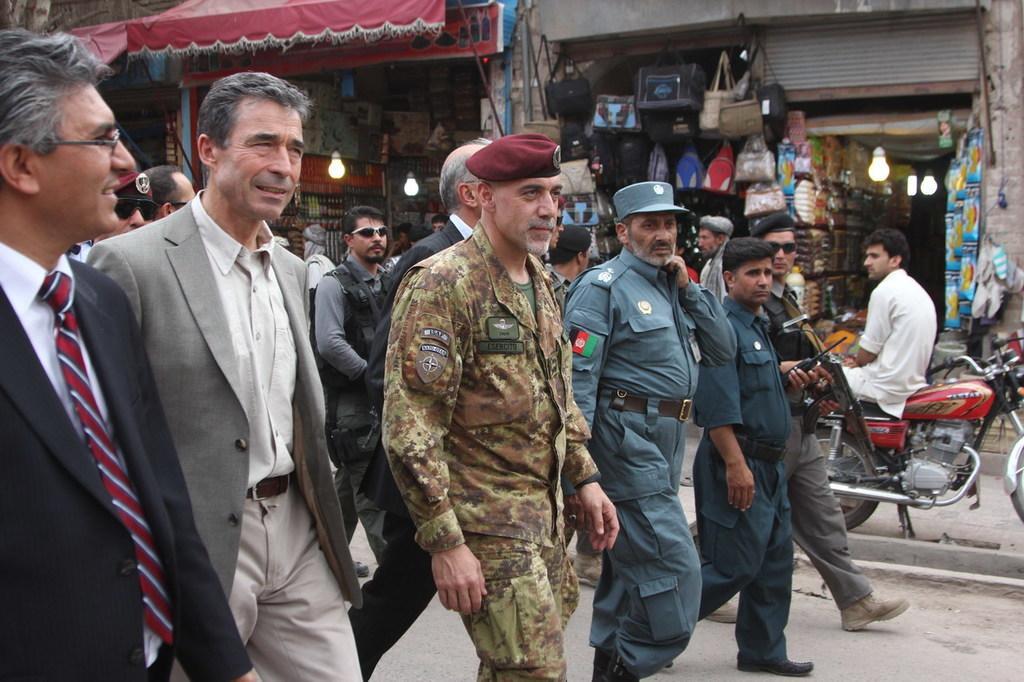Could you give a brief overview of what you see in this image? In this image there are a few persons walking on the road, in the background of the image there are few stalls and there is a person seated on a bike. 